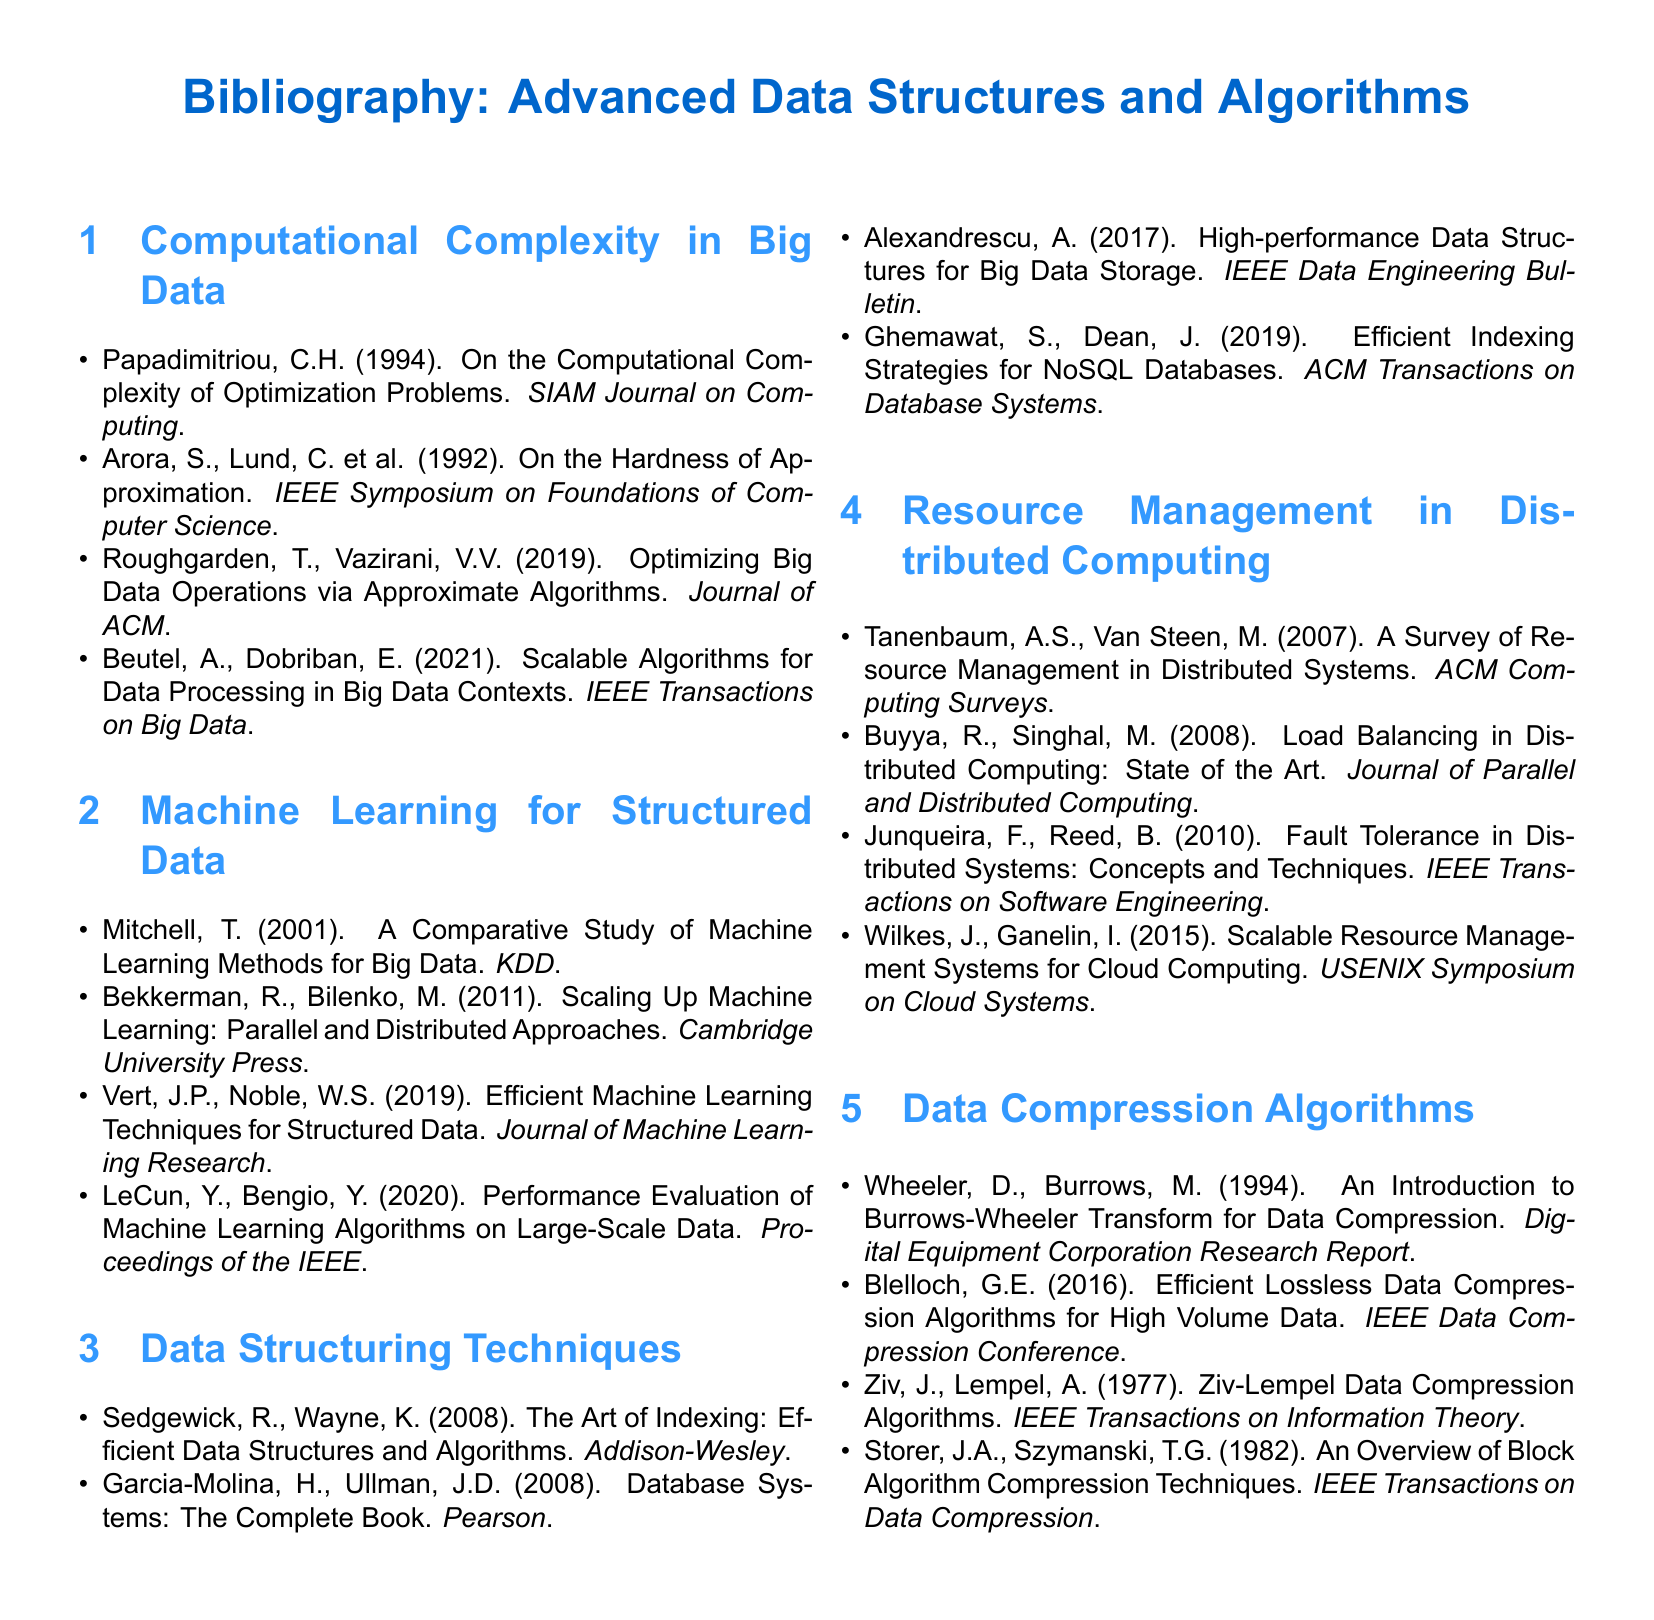What is the title of the bibliography? The title is presented at the top of the document and reflects the subject matter regarding advanced data structures and algorithms.
Answer: Advanced Data Structures and Algorithms Who is the author of the paper titled "The Art of Indexing: Efficient Data Structures and Algorithms"? The authors of this work are recognized as essential contributors to the field of data structures and algorithms.
Answer: Sedgewick, R., Wayne, K In which year was the paper "On the Hardness of Approximation" published? The publication year can be found within the citation details listed for this work in the bibliography.
Answer: 1992 What organization published the study on resource management in distributed systems? The organization is specified in the citation to illustrate the source of the research on resource management.
Answer: ACM How many papers are listed under the section "Data Compression Algorithms"? The total number of papers is determined by counting the items listed in this section of the bibliography.
Answer: Four Which paper discusses scalable algorithms for data processing? The inquiry pertains to identifying the specific reference related to scalable algorithms within the context of big data.
Answer: Scalable Algorithms for Data Processing in Big Data Contexts What is the main focus of the section on Resource Management in Distributed Computing? This focus can be discerned from the titles of the papers listed under this section regarding distributed systems.
Answer: Load balancing, fault tolerance, and scalability Which two authors collaborated on the "Efficient Machine Learning Techniques for Structured Data"? The collaboration is highlighted in the citation for this significant publication on machine learning methods.
Answer: Vert, J.P., Noble, W.S 